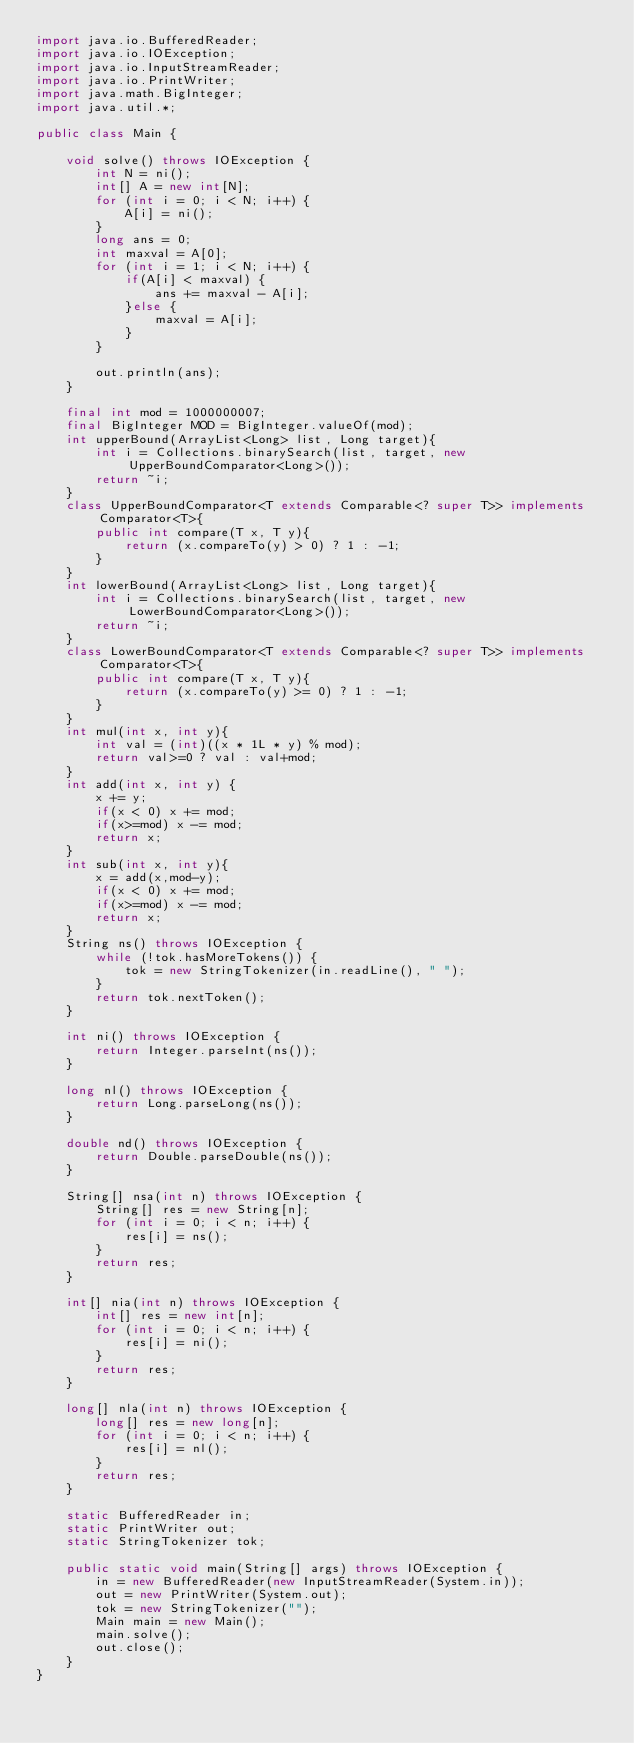<code> <loc_0><loc_0><loc_500><loc_500><_Java_>import java.io.BufferedReader;
import java.io.IOException;
import java.io.InputStreamReader;
import java.io.PrintWriter;
import java.math.BigInteger;
import java.util.*;
 
public class Main {
 
    void solve() throws IOException {
        int N = ni();
        int[] A = new int[N];
        for (int i = 0; i < N; i++) {
            A[i] = ni();
        }
        long ans = 0;
        int maxval = A[0];
        for (int i = 1; i < N; i++) {
            if(A[i] < maxval) {
                ans += maxval - A[i];
            }else {
                maxval = A[i];
            }
        }
 
        out.println(ans);
    }

    final int mod = 1000000007;
    final BigInteger MOD = BigInteger.valueOf(mod);
    int upperBound(ArrayList<Long> list, Long target){
        int i = Collections.binarySearch(list, target, new UpperBoundComparator<Long>());
        return ~i;
    }
    class UpperBoundComparator<T extends Comparable<? super T>> implements Comparator<T>{
        public int compare(T x, T y){
            return (x.compareTo(y) > 0) ? 1 : -1;
        }
    }
    int lowerBound(ArrayList<Long> list, Long target){
        int i = Collections.binarySearch(list, target, new LowerBoundComparator<Long>());
        return ~i;
    }
    class LowerBoundComparator<T extends Comparable<? super T>> implements Comparator<T>{
        public int compare(T x, T y){
            return (x.compareTo(y) >= 0) ? 1 : -1;
        }
    }
    int mul(int x, int y){
        int val = (int)((x * 1L * y) % mod);
        return val>=0 ? val : val+mod;
    }
    int add(int x, int y) {
        x += y;
        if(x < 0) x += mod;
        if(x>=mod) x -= mod;
        return x;
    }
    int sub(int x, int y){
        x = add(x,mod-y);
        if(x < 0) x += mod;
        if(x>=mod) x -= mod;
        return x;
    }
    String ns() throws IOException {
        while (!tok.hasMoreTokens()) {
            tok = new StringTokenizer(in.readLine(), " ");
        }
        return tok.nextToken();
    }
 
    int ni() throws IOException {
        return Integer.parseInt(ns());
    }
 
    long nl() throws IOException {
        return Long.parseLong(ns());
    }
 
    double nd() throws IOException {
        return Double.parseDouble(ns());
    }
 
    String[] nsa(int n) throws IOException {
        String[] res = new String[n];
        for (int i = 0; i < n; i++) {
            res[i] = ns();
        }
        return res;
    }
 
    int[] nia(int n) throws IOException {
        int[] res = new int[n];
        for (int i = 0; i < n; i++) {
            res[i] = ni();
        }
        return res;
    }
 
    long[] nla(int n) throws IOException {
        long[] res = new long[n];
        for (int i = 0; i < n; i++) {
            res[i] = nl();
        }
        return res;
    }
 
    static BufferedReader in;
    static PrintWriter out;
    static StringTokenizer tok;
 
    public static void main(String[] args) throws IOException {
        in = new BufferedReader(new InputStreamReader(System.in));
        out = new PrintWriter(System.out);
        tok = new StringTokenizer("");
        Main main = new Main();
        main.solve();
        out.close();
    }
}</code> 